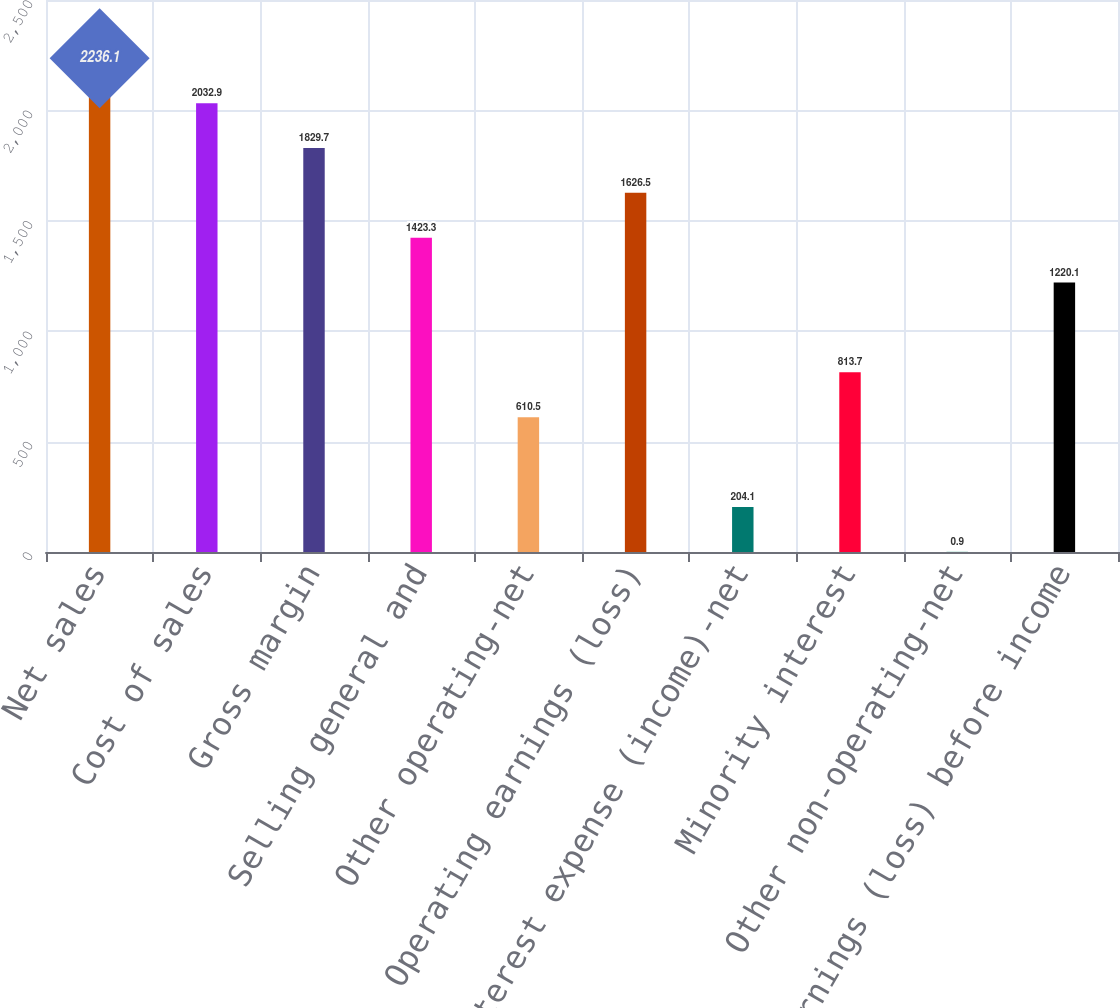Convert chart to OTSL. <chart><loc_0><loc_0><loc_500><loc_500><bar_chart><fcel>Net sales<fcel>Cost of sales<fcel>Gross margin<fcel>Selling general and<fcel>Other operating-net<fcel>Operating earnings (loss)<fcel>Interest expense (income)-net<fcel>Minority interest<fcel>Other non-operating-net<fcel>Earnings (loss) before income<nl><fcel>2236.1<fcel>2032.9<fcel>1829.7<fcel>1423.3<fcel>610.5<fcel>1626.5<fcel>204.1<fcel>813.7<fcel>0.9<fcel>1220.1<nl></chart> 